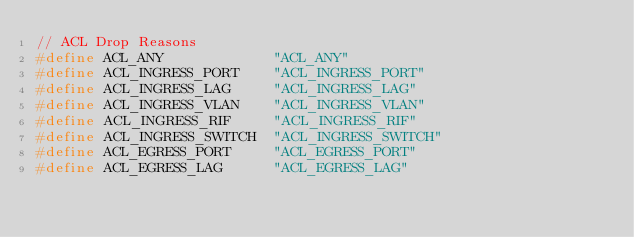Convert code to text. <code><loc_0><loc_0><loc_500><loc_500><_C_>// ACL Drop Reasons
#define ACL_ANY             "ACL_ANY"
#define ACL_INGRESS_PORT    "ACL_INGRESS_PORT"
#define ACL_INGRESS_LAG     "ACL_INGRESS_LAG"
#define ACL_INGRESS_VLAN    "ACL_INGRESS_VLAN"
#define ACL_INGRESS_RIF     "ACL_INGRESS_RIF"
#define ACL_INGRESS_SWITCH  "ACL_INGRESS_SWITCH"
#define ACL_EGRESS_PORT     "ACL_EGRESS_PORT"
#define ACL_EGRESS_LAG      "ACL_EGRESS_LAG"</code> 